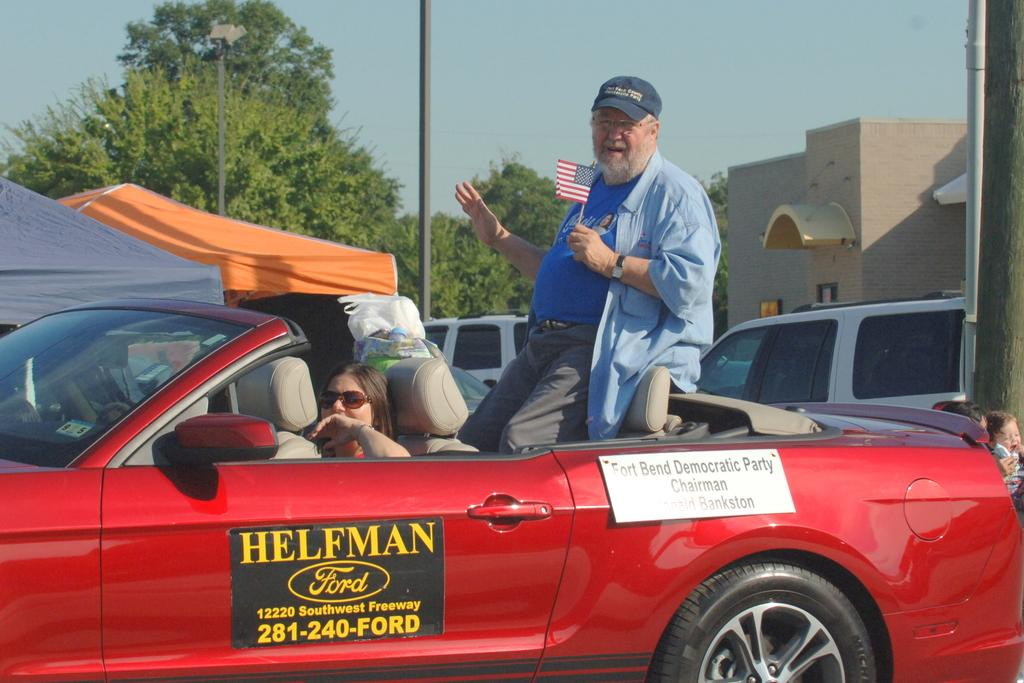What is the person standing in the car doing? The person is holding a flag. What is the person wearing? The person is wearing a cap. What is the position of the other person in the car? There is a person sitting in the car. What can be seen in the background of the image? Trees, buildings, cars, and poles are visible in the background. What type of mask is the person wearing in the image? There is no mask present in the image; the person is wearing a cap. What route is the person taking with the car in the image? The image does not provide information about the route the person is taking; it only shows the person standing in the car and holding a flag. 